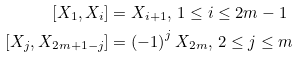Convert formula to latex. <formula><loc_0><loc_0><loc_500><loc_500>[ X _ { 1 } , X _ { i } ] & = X _ { i + 1 } , \, 1 \leq i \leq 2 m - 1 \\ [ X _ { j } , X _ { 2 m + 1 - j } ] & = \left ( - 1 \right ) ^ { j } X _ { 2 m } , \, 2 \leq j \leq m</formula> 